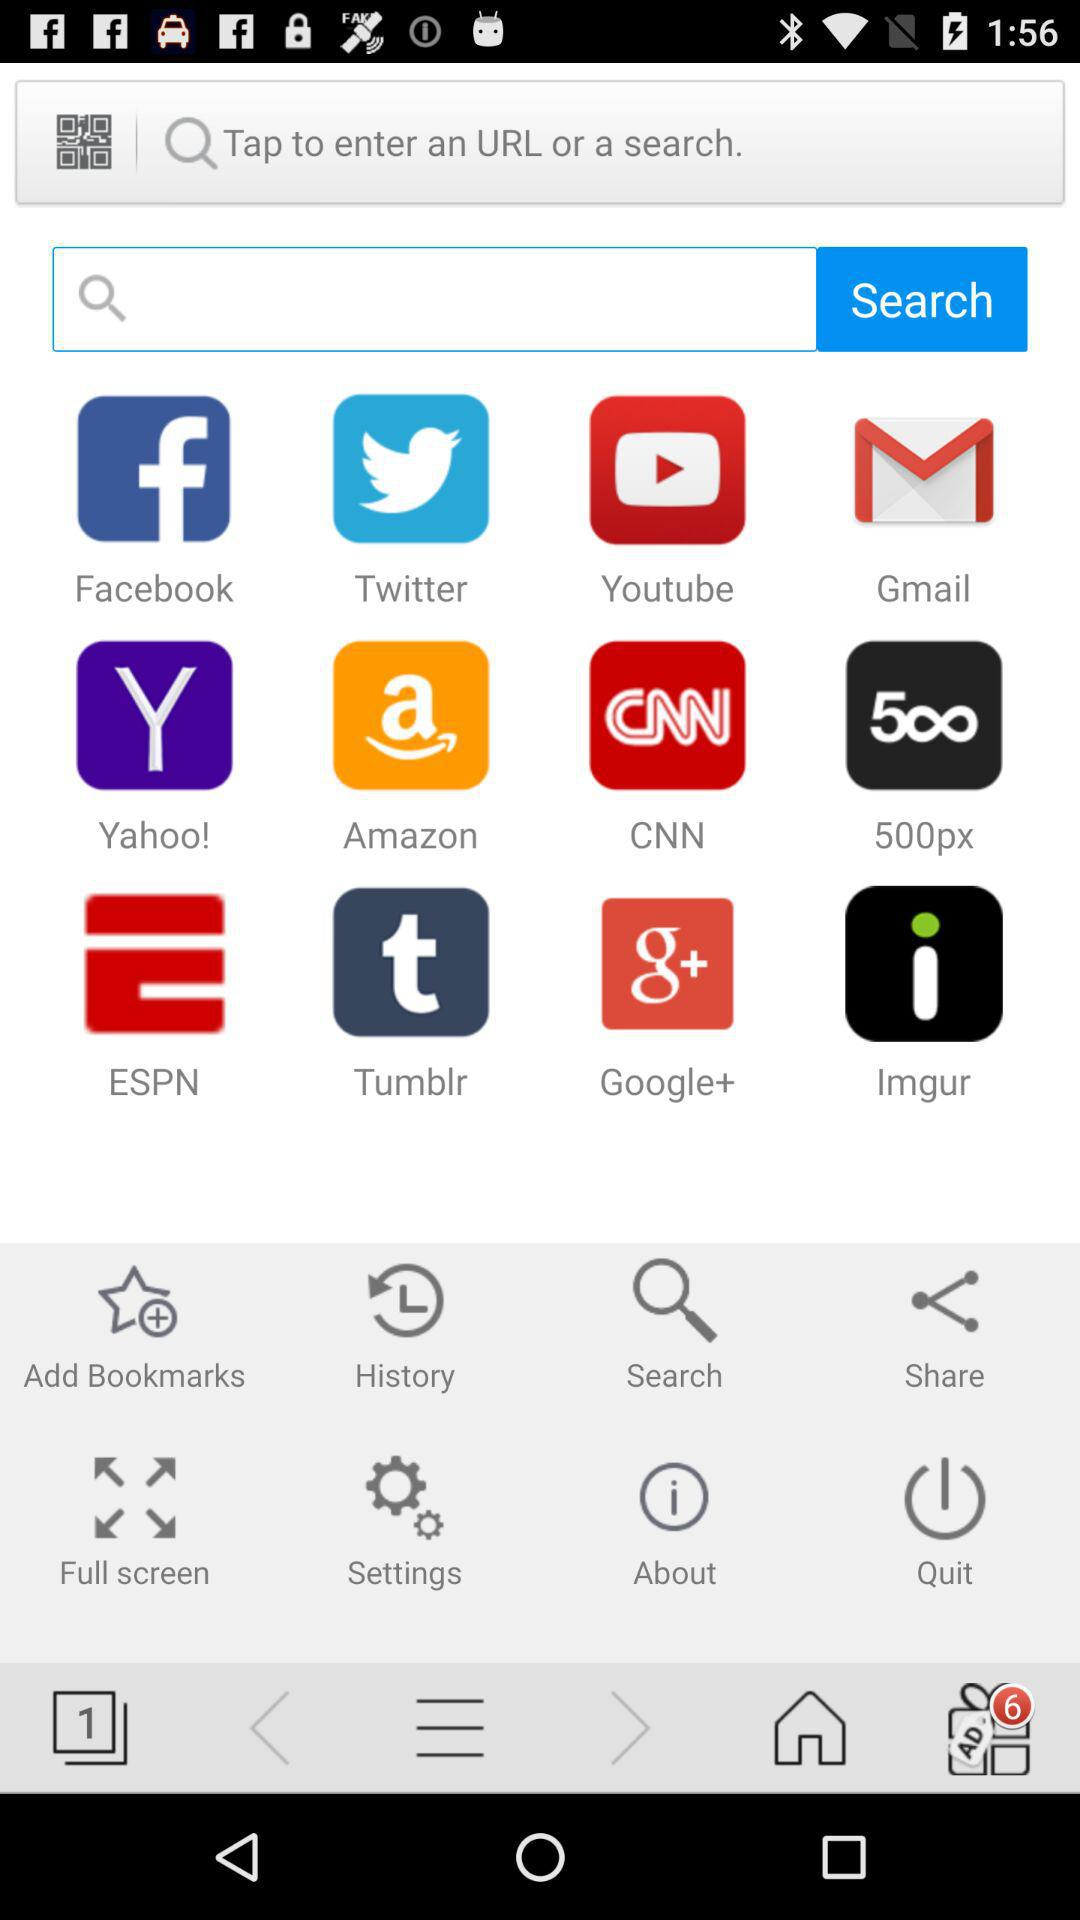What are the website shortcuts that I can use? You can use "Facebook", "Twitter", "Youtube", "Gmail", "Yahoo!", "Amazon", "CNN", "500px", "ESPN", "Tumblr", "Google+" and "Imgur" website shortcuts. 